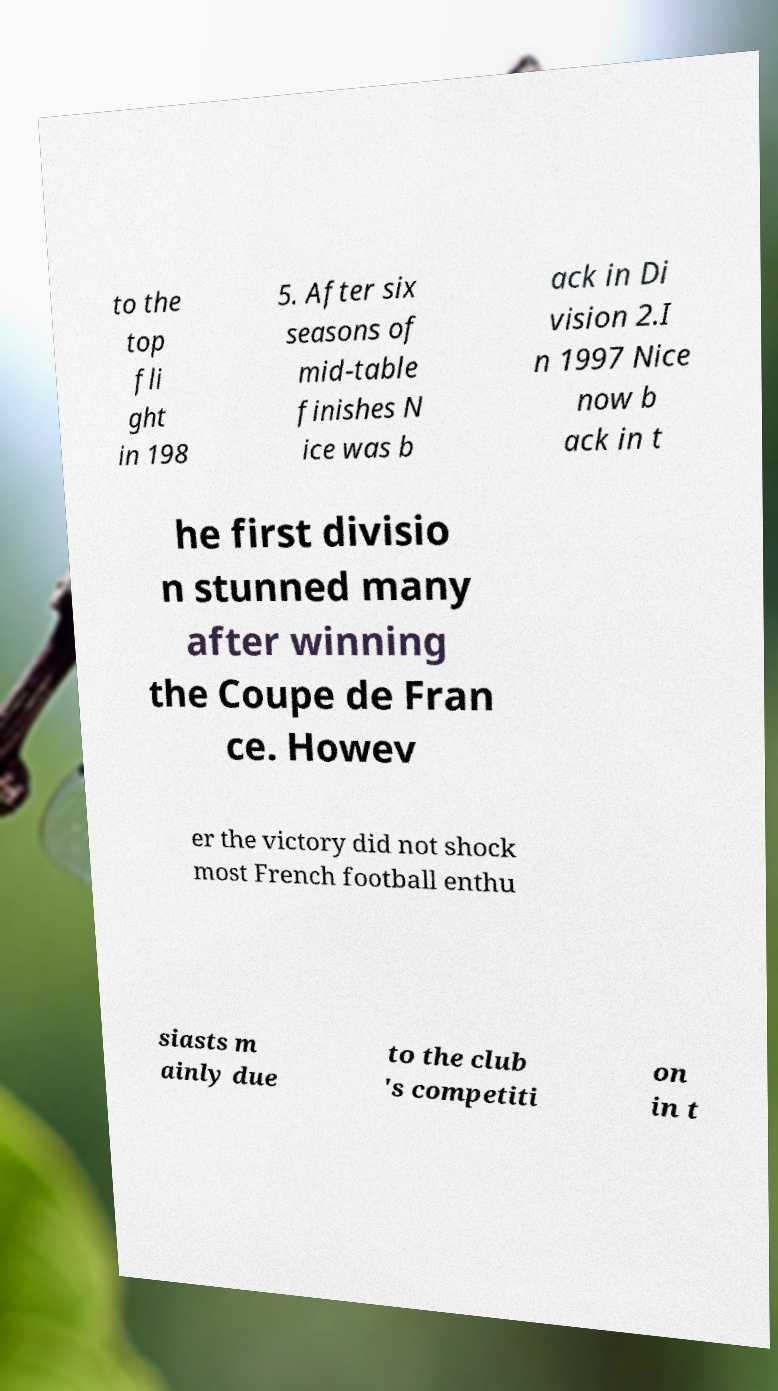Can you read and provide the text displayed in the image?This photo seems to have some interesting text. Can you extract and type it out for me? to the top fli ght in 198 5. After six seasons of mid-table finishes N ice was b ack in Di vision 2.I n 1997 Nice now b ack in t he first divisio n stunned many after winning the Coupe de Fran ce. Howev er the victory did not shock most French football enthu siasts m ainly due to the club 's competiti on in t 